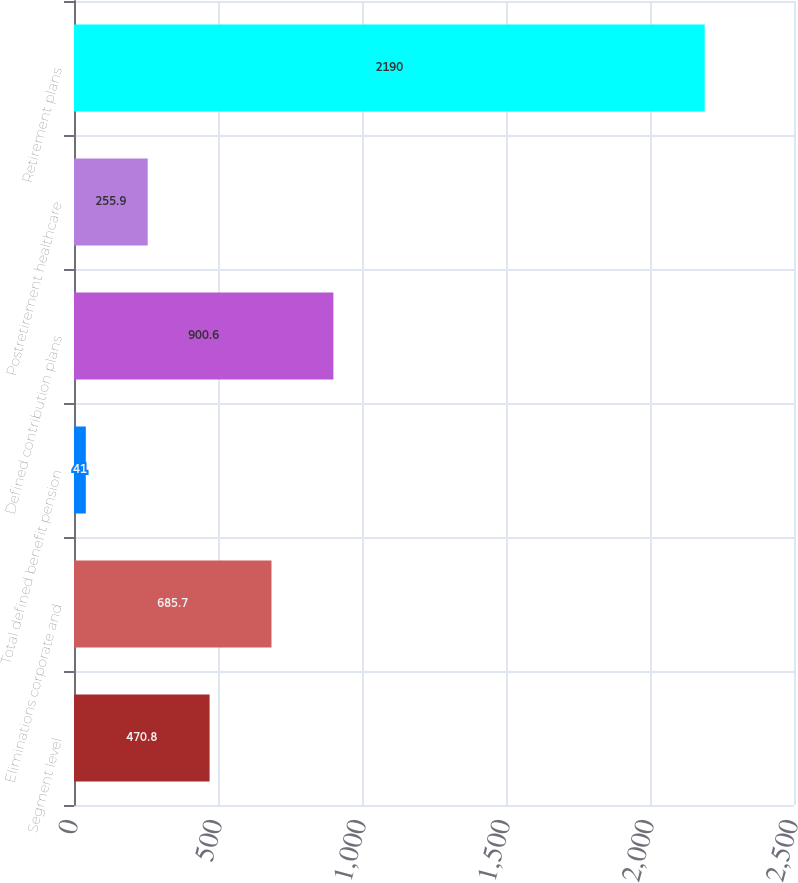Convert chart. <chart><loc_0><loc_0><loc_500><loc_500><bar_chart><fcel>Segment level<fcel>Eliminations corporate and<fcel>Total defined benefit pension<fcel>Defined contribution plans<fcel>Postretirement healthcare<fcel>Retirement plans<nl><fcel>470.8<fcel>685.7<fcel>41<fcel>900.6<fcel>255.9<fcel>2190<nl></chart> 